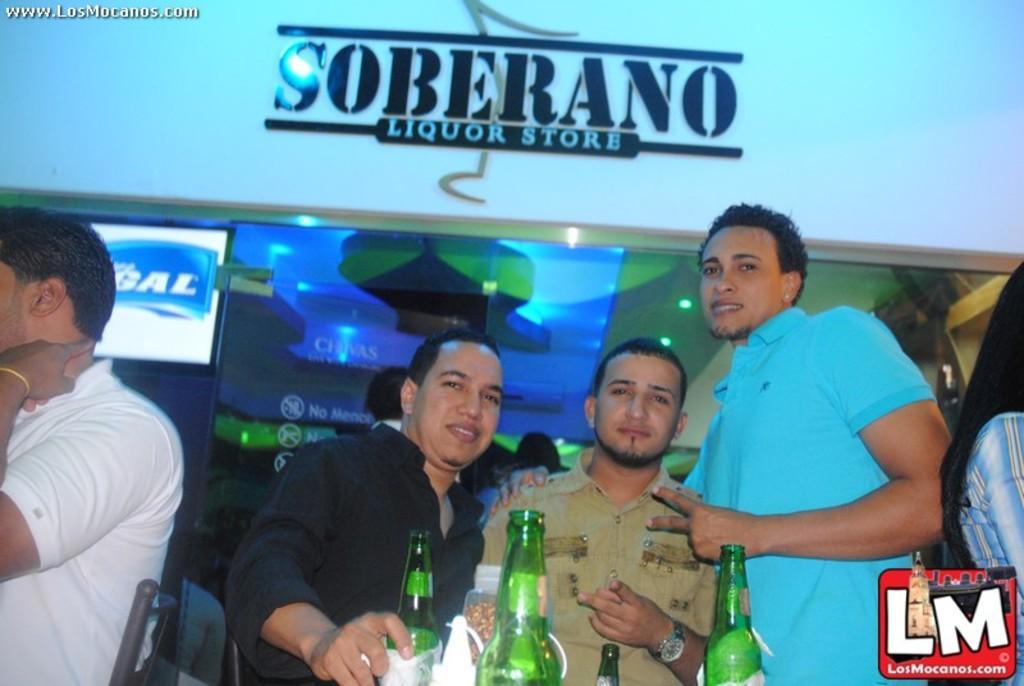In one or two sentences, can you explain what this image depicts? In this picture there are three men posing for a picture. In front of them there are some bottles. In the background, there is a wall and a glass here to which a television is attached. 